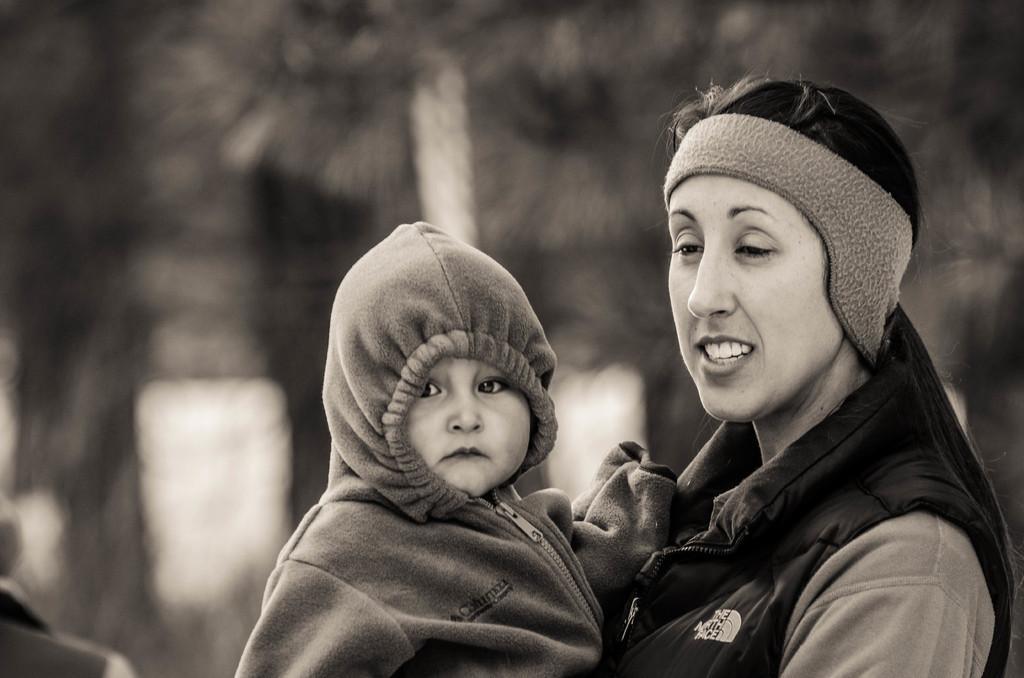In one or two sentences, can you explain what this image depicts? This is a black and white picture. The woman in front of the picture wearing a black jacket is holding a baby in her hands. The baby is wearing a jacket. She is smiling. Behind her, we see something in white color. It is blurred in the background. 